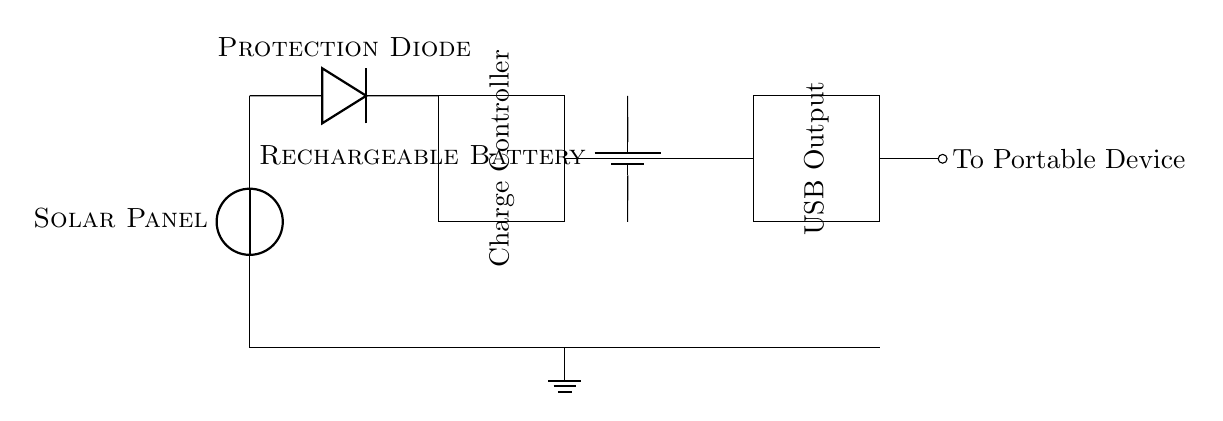What is the primary function of the solar panel in this circuit? The solar panel converts sunlight into electrical energy, which is essential for powering the circuit and charging the battery.
Answer: Converts sunlight What component protects the circuit from reverse current? The protection diode allows current to flow in one direction and blocks it when it tries to reverse, preventing damage to other components like the battery.
Answer: Protection diode What component stores energy in the circuit? The rechargeable battery is the component that accumulates electrical energy generated by the solar panel for later use in powering portable devices.
Answer: Rechargeable battery What is the output type from the USB output? The USB output is designed to provide a standard power interface for connecting and charging portable devices.
Answer: Power interface What is the maximum current output expected from the USB output? While the circuit does not specify the exact maximum current, typical USB outputs usually range from 0.5A to 2.1A. The current will depend on the solar panel's generation capacity and the connected device's demand.
Answer: Depends on demand How does the charge controller function in this circuit? The charge controller manages the current flowing to the battery, ensuring it is charged efficiently while preventing overcharging or deep discharging which can damage the battery.
Answer: Manages battery charging What can happen if the diode is removed from the circuit? Without the diode, any reverse current from the battery could flow back to the solar panel, potentially damaging it and affecting the charging process.
Answer: Damage to components 